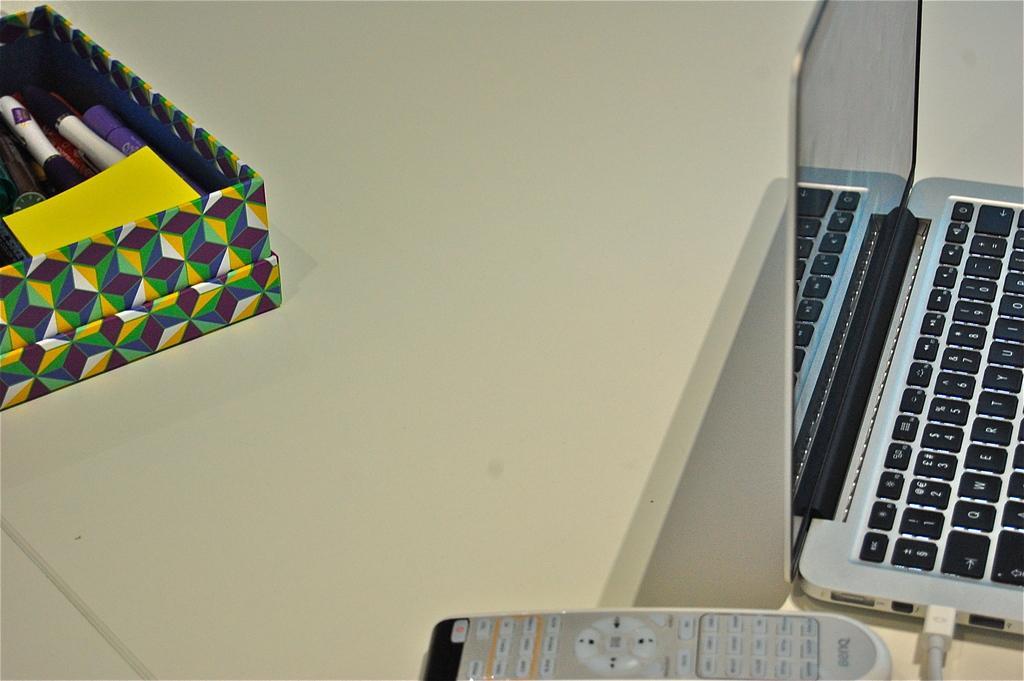Can you describe this image briefly? In this image on the right side there is a laptop and in the front there is a remote. On the left side there is a box and in the box there are pens and there is a paper. 